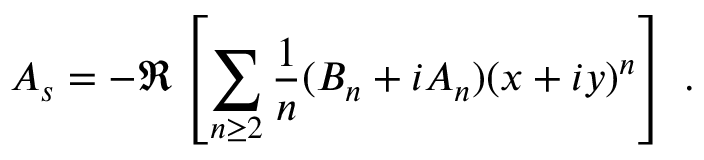<formula> <loc_0><loc_0><loc_500><loc_500>A _ { s } = - \Re \left [ \sum _ { n \geq 2 } \frac { 1 } { n } ( B _ { n } + i A _ { n } ) ( x + i y ) ^ { n } \right ] \, .</formula> 